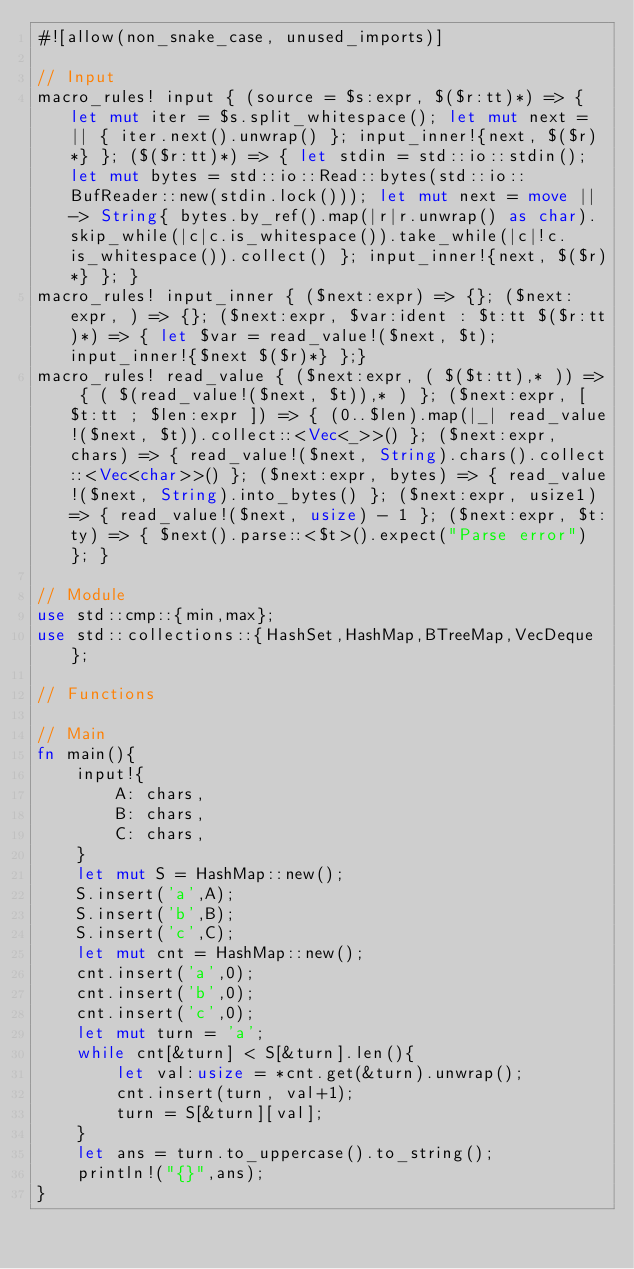Convert code to text. <code><loc_0><loc_0><loc_500><loc_500><_Rust_>#![allow(non_snake_case, unused_imports)]

// Input
macro_rules! input { (source = $s:expr, $($r:tt)*) => { let mut iter = $s.split_whitespace(); let mut next = || { iter.next().unwrap() }; input_inner!{next, $($r)*} }; ($($r:tt)*) => { let stdin = std::io::stdin(); let mut bytes = std::io::Read::bytes(std::io::BufReader::new(stdin.lock())); let mut next = move || -> String{ bytes.by_ref().map(|r|r.unwrap() as char).skip_while(|c|c.is_whitespace()).take_while(|c|!c.is_whitespace()).collect() }; input_inner!{next, $($r)*} }; }
macro_rules! input_inner { ($next:expr) => {}; ($next:expr, ) => {}; ($next:expr, $var:ident : $t:tt $($r:tt)*) => { let $var = read_value!($next, $t); input_inner!{$next $($r)*} };}
macro_rules! read_value { ($next:expr, ( $($t:tt),* )) => { ( $(read_value!($next, $t)),* ) }; ($next:expr, [ $t:tt ; $len:expr ]) => { (0..$len).map(|_| read_value!($next, $t)).collect::<Vec<_>>() }; ($next:expr, chars) => { read_value!($next, String).chars().collect::<Vec<char>>() }; ($next:expr, bytes) => { read_value!($next, String).into_bytes() }; ($next:expr, usize1) => { read_value!($next, usize) - 1 }; ($next:expr, $t:ty) => { $next().parse::<$t>().expect("Parse error") }; }

// Module
use std::cmp::{min,max};
use std::collections::{HashSet,HashMap,BTreeMap,VecDeque};

// Functions

// Main
fn main(){
    input!{
        A: chars,
        B: chars,
        C: chars,
    }
    let mut S = HashMap::new();
    S.insert('a',A);
    S.insert('b',B);
    S.insert('c',C);
    let mut cnt = HashMap::new();
    cnt.insert('a',0);
    cnt.insert('b',0);
    cnt.insert('c',0);
    let mut turn = 'a';
    while cnt[&turn] < S[&turn].len(){
        let val:usize = *cnt.get(&turn).unwrap();
        cnt.insert(turn, val+1);
        turn = S[&turn][val];
    }
    let ans = turn.to_uppercase().to_string();
    println!("{}",ans);
}</code> 